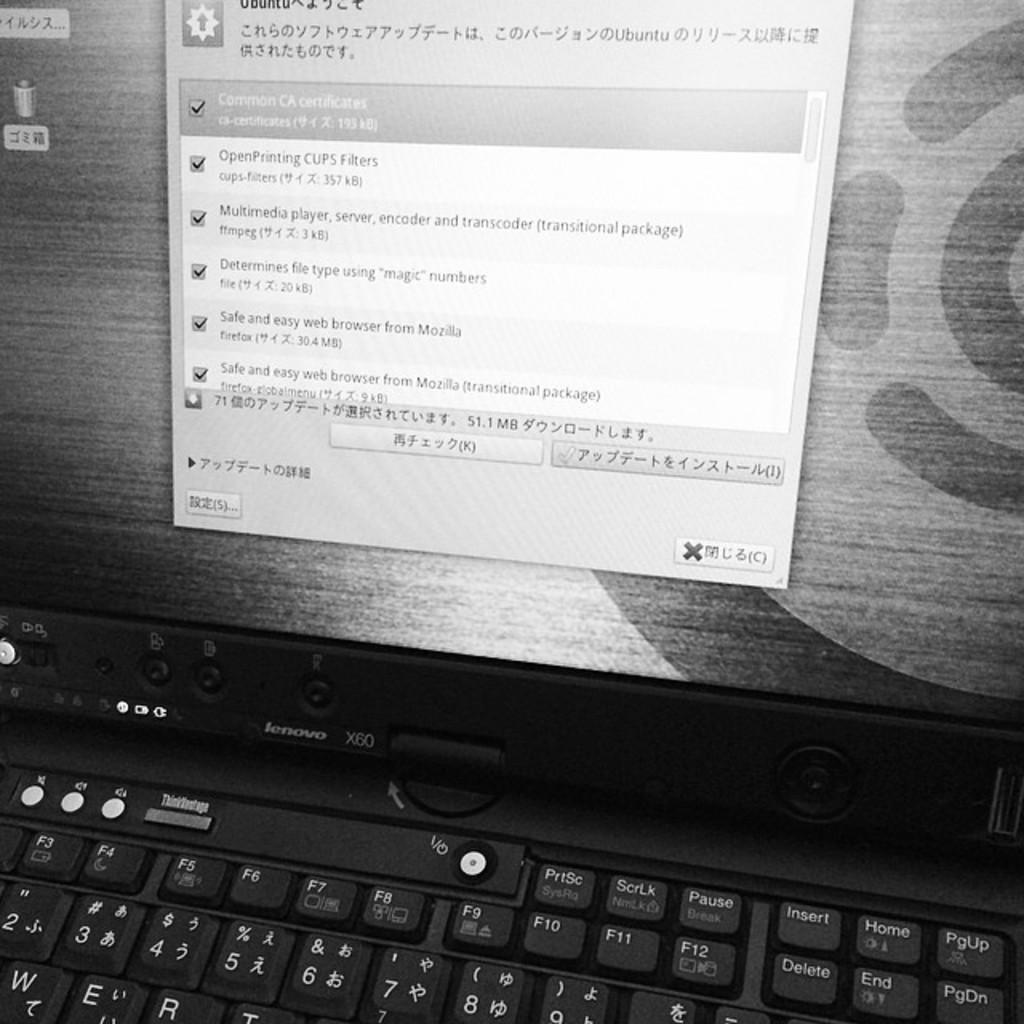<image>
Create a compact narrative representing the image presented. A laptop computer with an open app written in a different language. 